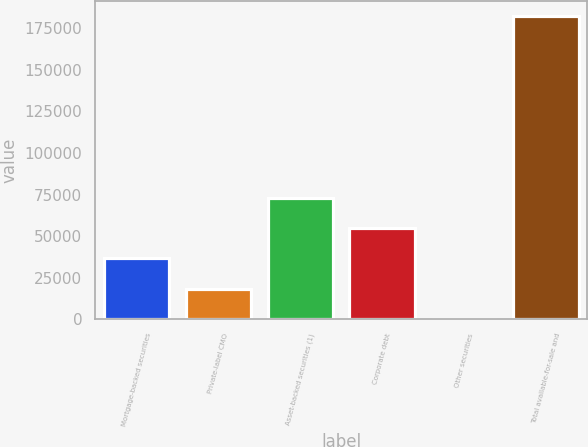Convert chart. <chart><loc_0><loc_0><loc_500><loc_500><bar_chart><fcel>Mortgage-backed securities<fcel>Private-label CMO<fcel>Asset-backed securities (1)<fcel>Corporate debt<fcel>Other securities<fcel>Total available-for-sale and<nl><fcel>36653.6<fcel>18493.3<fcel>72974.2<fcel>54813.9<fcel>333<fcel>181936<nl></chart> 